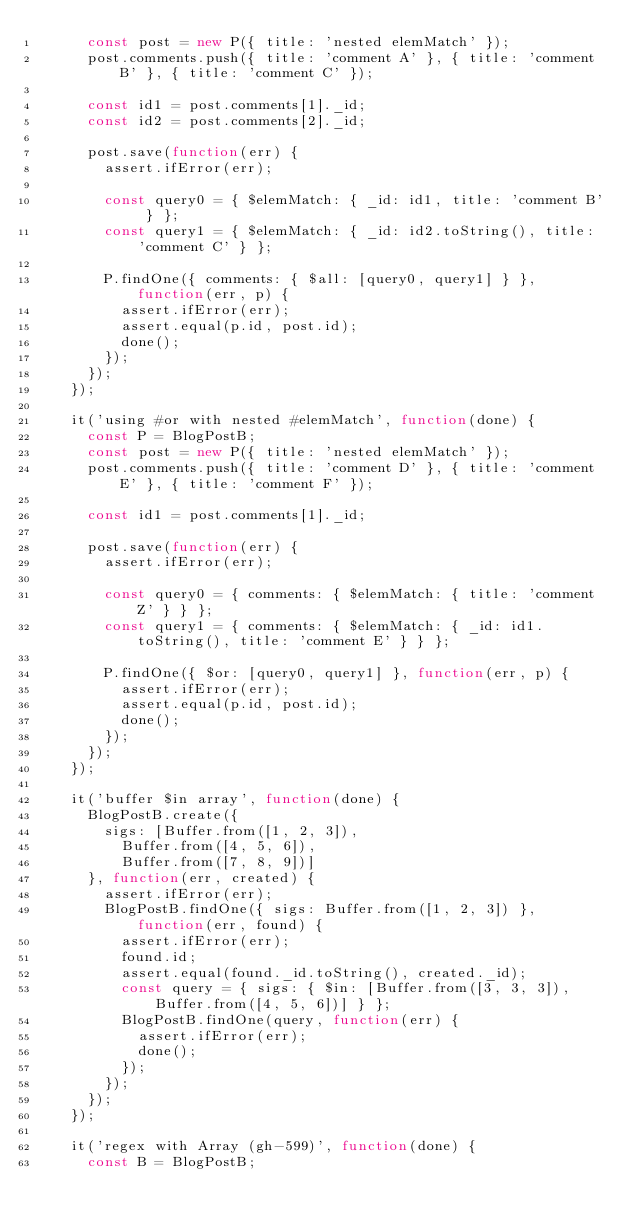Convert code to text. <code><loc_0><loc_0><loc_500><loc_500><_JavaScript_>      const post = new P({ title: 'nested elemMatch' });
      post.comments.push({ title: 'comment A' }, { title: 'comment B' }, { title: 'comment C' });

      const id1 = post.comments[1]._id;
      const id2 = post.comments[2]._id;

      post.save(function(err) {
        assert.ifError(err);

        const query0 = { $elemMatch: { _id: id1, title: 'comment B' } };
        const query1 = { $elemMatch: { _id: id2.toString(), title: 'comment C' } };

        P.findOne({ comments: { $all: [query0, query1] } }, function(err, p) {
          assert.ifError(err);
          assert.equal(p.id, post.id);
          done();
        });
      });
    });

    it('using #or with nested #elemMatch', function(done) {
      const P = BlogPostB;
      const post = new P({ title: 'nested elemMatch' });
      post.comments.push({ title: 'comment D' }, { title: 'comment E' }, { title: 'comment F' });

      const id1 = post.comments[1]._id;

      post.save(function(err) {
        assert.ifError(err);

        const query0 = { comments: { $elemMatch: { title: 'comment Z' } } };
        const query1 = { comments: { $elemMatch: { _id: id1.toString(), title: 'comment E' } } };

        P.findOne({ $or: [query0, query1] }, function(err, p) {
          assert.ifError(err);
          assert.equal(p.id, post.id);
          done();
        });
      });
    });

    it('buffer $in array', function(done) {
      BlogPostB.create({
        sigs: [Buffer.from([1, 2, 3]),
          Buffer.from([4, 5, 6]),
          Buffer.from([7, 8, 9])]
      }, function(err, created) {
        assert.ifError(err);
        BlogPostB.findOne({ sigs: Buffer.from([1, 2, 3]) }, function(err, found) {
          assert.ifError(err);
          found.id;
          assert.equal(found._id.toString(), created._id);
          const query = { sigs: { $in: [Buffer.from([3, 3, 3]), Buffer.from([4, 5, 6])] } };
          BlogPostB.findOne(query, function(err) {
            assert.ifError(err);
            done();
          });
        });
      });
    });

    it('regex with Array (gh-599)', function(done) {
      const B = BlogPostB;</code> 